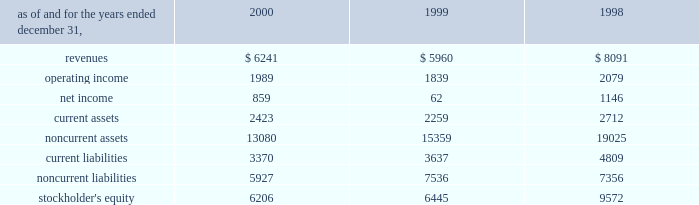A e s 2 0 0 0 f i n a n c i a l r e v i e w in may 2000 , a subsidiary of the company acquired an additional 5% ( 5 % ) of the preferred , non-voting shares of eletropaulo for approximately $ 90 million .
In january 2000 , 59% ( 59 % ) of the preferred non-voting shares were acquired for approximately $ 1 billion at auction from bndes , the national development bank of brazil .
The price established at auction was approximately $ 72.18 per 1000 shares , to be paid in four annual installments com- mencing with a payment of 18.5% ( 18.5 % ) of the total price upon closing of the transaction and installments of 25.9% ( 25.9 % ) , 27.1% ( 27.1 % ) and 28.5% ( 28.5 % ) of the total price to be paid annually thereafter .
At december 31 , 2000 , the company had a total economic interest of 49.6% ( 49.6 % ) in eletropaulo .
The company accounts for this investment using the equity method based on the related consortium agreement that allows the exercise of significant influence .
In august 2000 , a subsidiary of the company acquired a 49% ( 49 % ) interest in songas limited for approxi- mately $ 40 million .
Songas limited owns the songo songo gas-to-electricity project in tanzania .
Under the terms of a project management agreement , the company has assumed overall project management responsibility .
The project consists of the refurbishment and operation of five natural gas wells in coastal tanzania , the construction and operation of a 65 mmscf/day gas processing plant and related facilities , the construction of a 230 km marine and land pipeline from the gas plant to dar es salaam and the conversion and upgrading of an existing 112 mw power station in dar es salaam to burn natural gas , with an optional additional unit to be constructed at the plant .
Since the project is currently under construction , no rev- enues or expenses have been incurred , and therefore no results are shown in the table .
In december 2000 , a subsidiary of the company with edf international s.a .
( 201cedf 201d ) completed the acquisition of an additional 3.5% ( 3.5 % ) interest in light from two sub- sidiaries of reliant energy for approximately $ 136 mil- lion .
Pursuant to the acquisition , the company acquired 30% ( 30 % ) of the shares while edf acquired the remainder .
With the completion of this transaction , the company owns approximately 21.14% ( 21.14 % ) of light .
In december 2000 , a subsidiary of the company entered into an agreement with edf to jointly acquire an additional 9.2% ( 9.2 % ) interest in light , which is held by a sub- sidiary of companhia siderurgica nacional ( 201ccsn 201d ) .
Pursuant to this transaction , the company acquired an additional 2.75% ( 2.75 % ) interest in light for $ 114.6 million .
This transaction closed in january 2001 .
Following the purchase of the light shares previously owned by csn , aes and edf will together be the con- trolling shareholders of light and eletropaulo .
Aes and edf have agreed that aes will eventually take operational control of eletropaulo and the telecom businesses of light and eletropaulo , while edf will eventually take opera- tional control of light and eletropaulo 2019s electric workshop business .
Aes and edf intend to continue to pursue a fur- ther rationalization of their ownership stakes in light and eletropaulo , the result of which aes would become the sole controlling shareholder of eletropaulo and edf would become the sole controlling shareholder of light .
Upon consummation of the transaction , aes will begin consolidating eletropaulo 2019s operating results .
The struc- ture and process by which this rationalization may be effected , and the resulting timing , have yet to be deter- mined and will likely be subject to approval by various brazilian regulatory authorities and other third parties .
As a result , there can be no assurance that this rationalization will take place .
In may 1999 , a subsidiary of the company acquired subscription rights from the brazilian state-controlled eletrobras which allowed it to purchase preferred , non- voting shares in eletropaulo and common shares in light .
The aggregate purchase price of the subscription rights and the underlying shares in light and eletropaulo was approximately $ 53 million and $ 77 million , respectively , and represented 3.7% ( 3.7 % ) and 4.4% ( 4.4 % ) economic ownership interest in their capital stock , respectively .
The table presents summarized financial information ( in millions ) for the company 2019s investments in 50% ( 50 % ) or less owned investments accounted for using the equity method: .

What was the change in revenue for the company 2019s investments in 50% ( 50 % ) or less owned investments accounted for using the equity method between 1998 and 1999? 
Computations: ((5960 - 8091) / 8091)
Answer: -0.26338. 